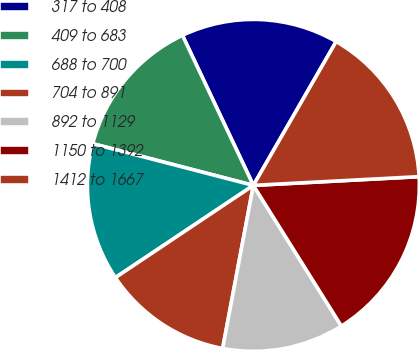Convert chart to OTSL. <chart><loc_0><loc_0><loc_500><loc_500><pie_chart><fcel>317 to 408<fcel>409 to 683<fcel>688 to 700<fcel>704 to 891<fcel>892 to 1129<fcel>1150 to 1392<fcel>1412 to 1667<nl><fcel>15.34%<fcel>13.93%<fcel>13.42%<fcel>12.66%<fcel>11.86%<fcel>16.94%<fcel>15.85%<nl></chart> 